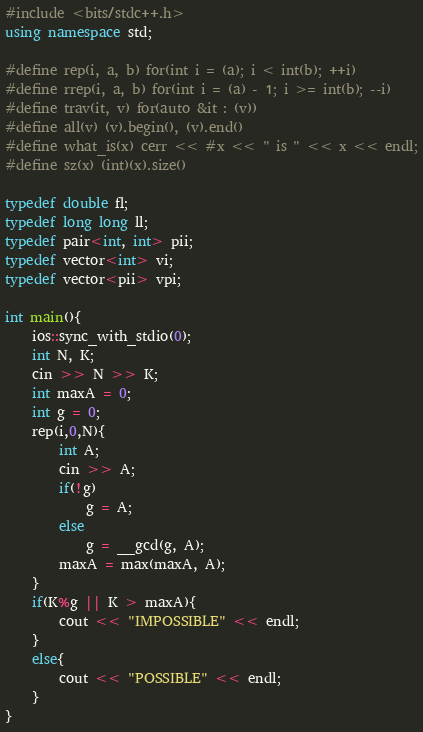Convert code to text. <code><loc_0><loc_0><loc_500><loc_500><_C++_>#include <bits/stdc++.h>
using namespace std;

#define rep(i, a, b) for(int i = (a); i < int(b); ++i)
#define rrep(i, a, b) for(int i = (a) - 1; i >= int(b); --i)
#define trav(it, v) for(auto &it : (v))
#define all(v) (v).begin(), (v).end()
#define what_is(x) cerr << #x << " is " << x << endl;
#define sz(x) (int)(x).size()

typedef double fl;
typedef long long ll;
typedef pair<int, int> pii;
typedef vector<int> vi;
typedef vector<pii> vpi;

int main(){
	ios::sync_with_stdio(0);
	int N, K;
	cin >> N >> K;
	int maxA = 0;
	int g = 0;
	rep(i,0,N){
		int A;
		cin >> A;
		if(!g)
			g = A;
		else
			g = __gcd(g, A);
		maxA = max(maxA, A);
	}
	if(K%g || K > maxA){
		cout << "IMPOSSIBLE" << endl;
	}
	else{
		cout << "POSSIBLE" << endl;
	}
}</code> 